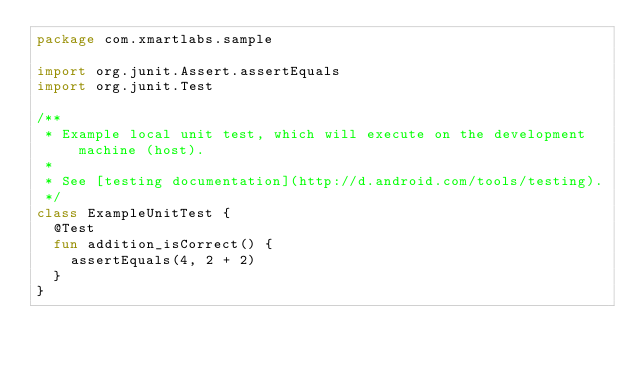<code> <loc_0><loc_0><loc_500><loc_500><_Kotlin_>package com.xmartlabs.sample

import org.junit.Assert.assertEquals
import org.junit.Test

/**
 * Example local unit test, which will execute on the development machine (host).
 *
 * See [testing documentation](http://d.android.com/tools/testing).
 */
class ExampleUnitTest {
  @Test
  fun addition_isCorrect() {
    assertEquals(4, 2 + 2)
  }
}
</code> 